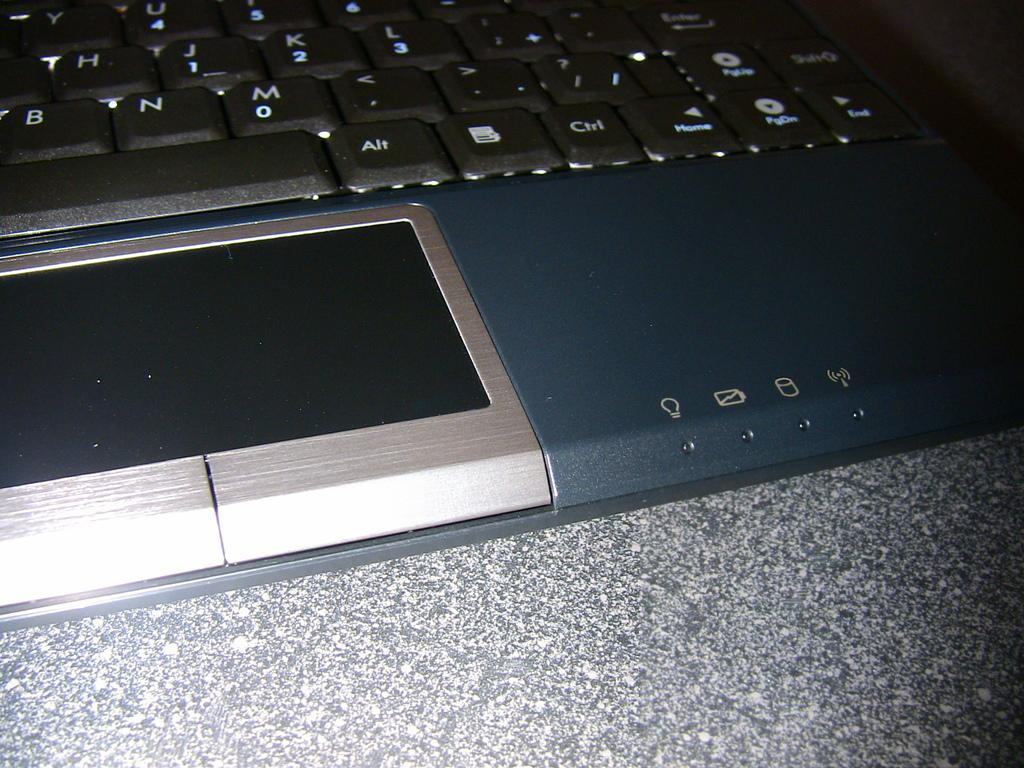<image>
Offer a succinct explanation of the picture presented. a keyboard with a control key on it 